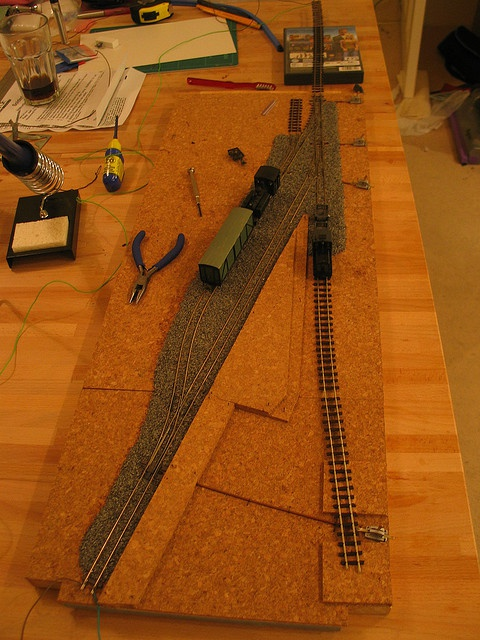Describe the objects in this image and their specific colors. I can see cup in brown, olive, maroon, and black tones and train in brown, black, olive, and maroon tones in this image. 